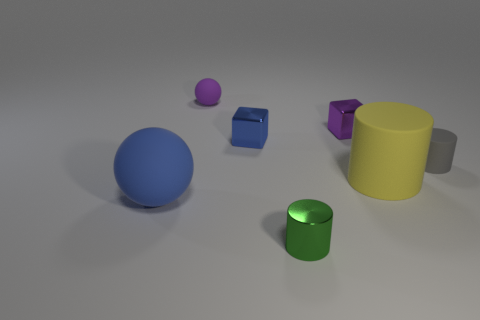Is there any other thing that has the same color as the metal cylinder?
Your response must be concise. No. There is a small thing that is the same color as the small rubber ball; what shape is it?
Make the answer very short. Cube. There is a small block right of the small shiny thing that is in front of the thing that is on the left side of the tiny ball; what is it made of?
Offer a terse response. Metal. There is a green object that is made of the same material as the purple block; what is its size?
Your response must be concise. Small. Is there a cube of the same color as the tiny matte sphere?
Your answer should be very brief. Yes. There is a gray cylinder; is it the same size as the metal thing that is in front of the big cylinder?
Offer a very short reply. Yes. There is a blue object that is behind the large rubber thing that is to the left of the purple sphere; what number of small metal objects are to the right of it?
Your response must be concise. 2. The cube that is the same color as the big matte ball is what size?
Offer a very short reply. Small. Are there any objects right of the tiny purple matte sphere?
Provide a short and direct response. Yes. There is a tiny gray thing; what shape is it?
Make the answer very short. Cylinder. 